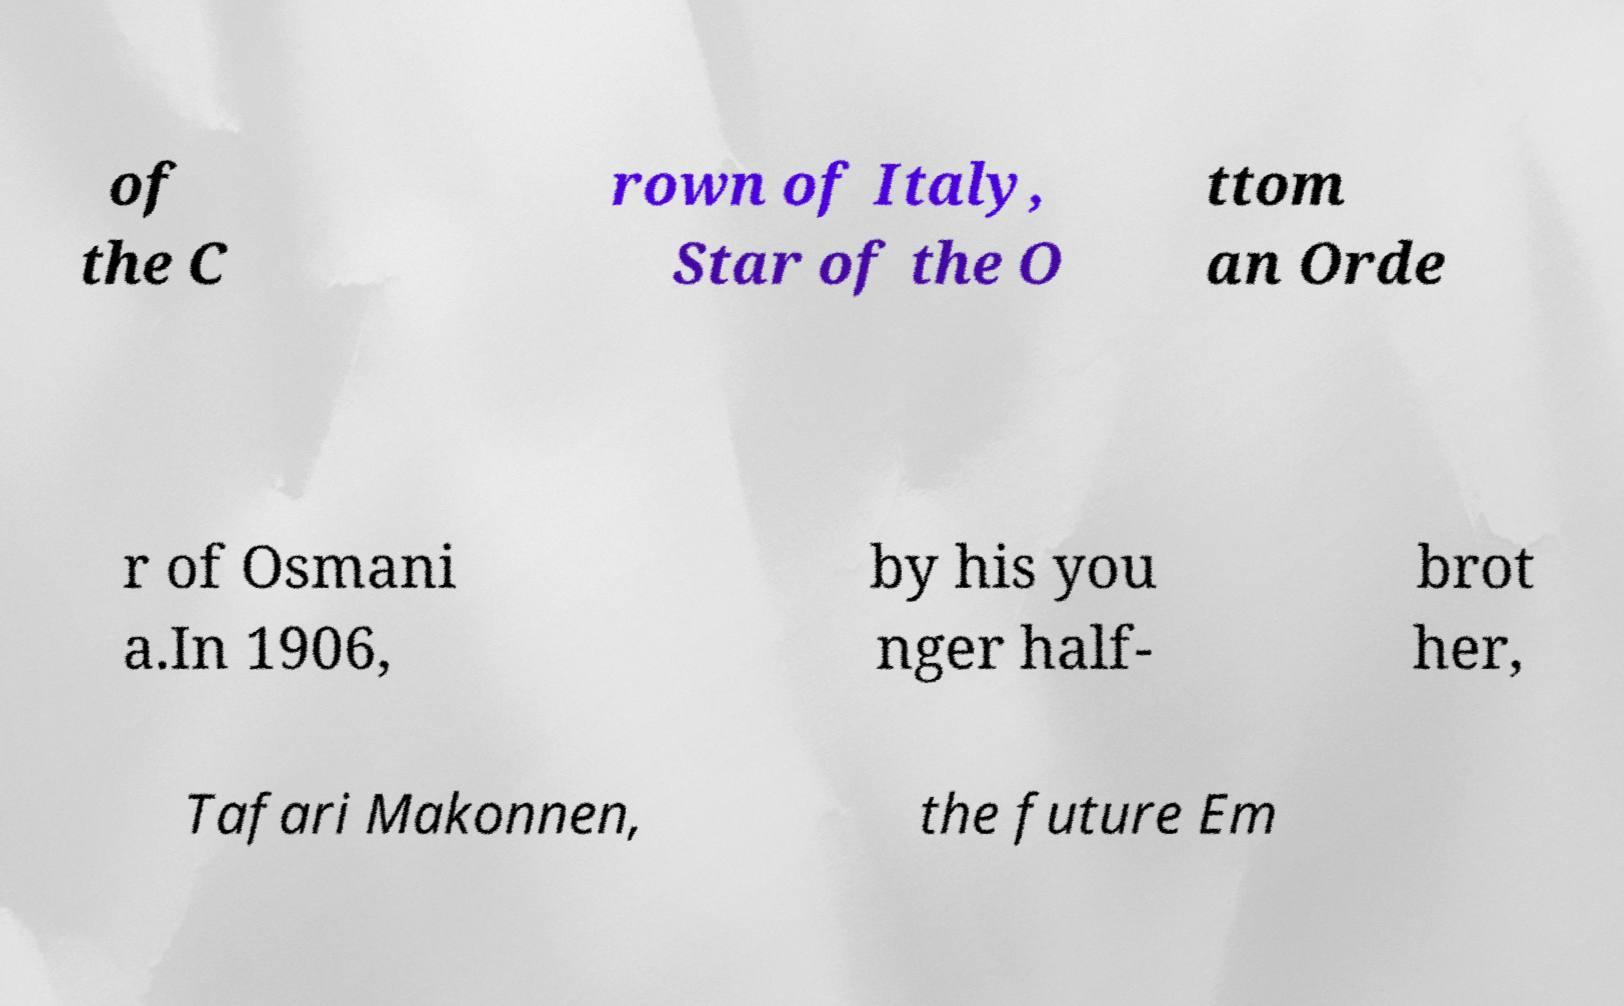Could you assist in decoding the text presented in this image and type it out clearly? of the C rown of Italy, Star of the O ttom an Orde r of Osmani a.In 1906, by his you nger half- brot her, Tafari Makonnen, the future Em 